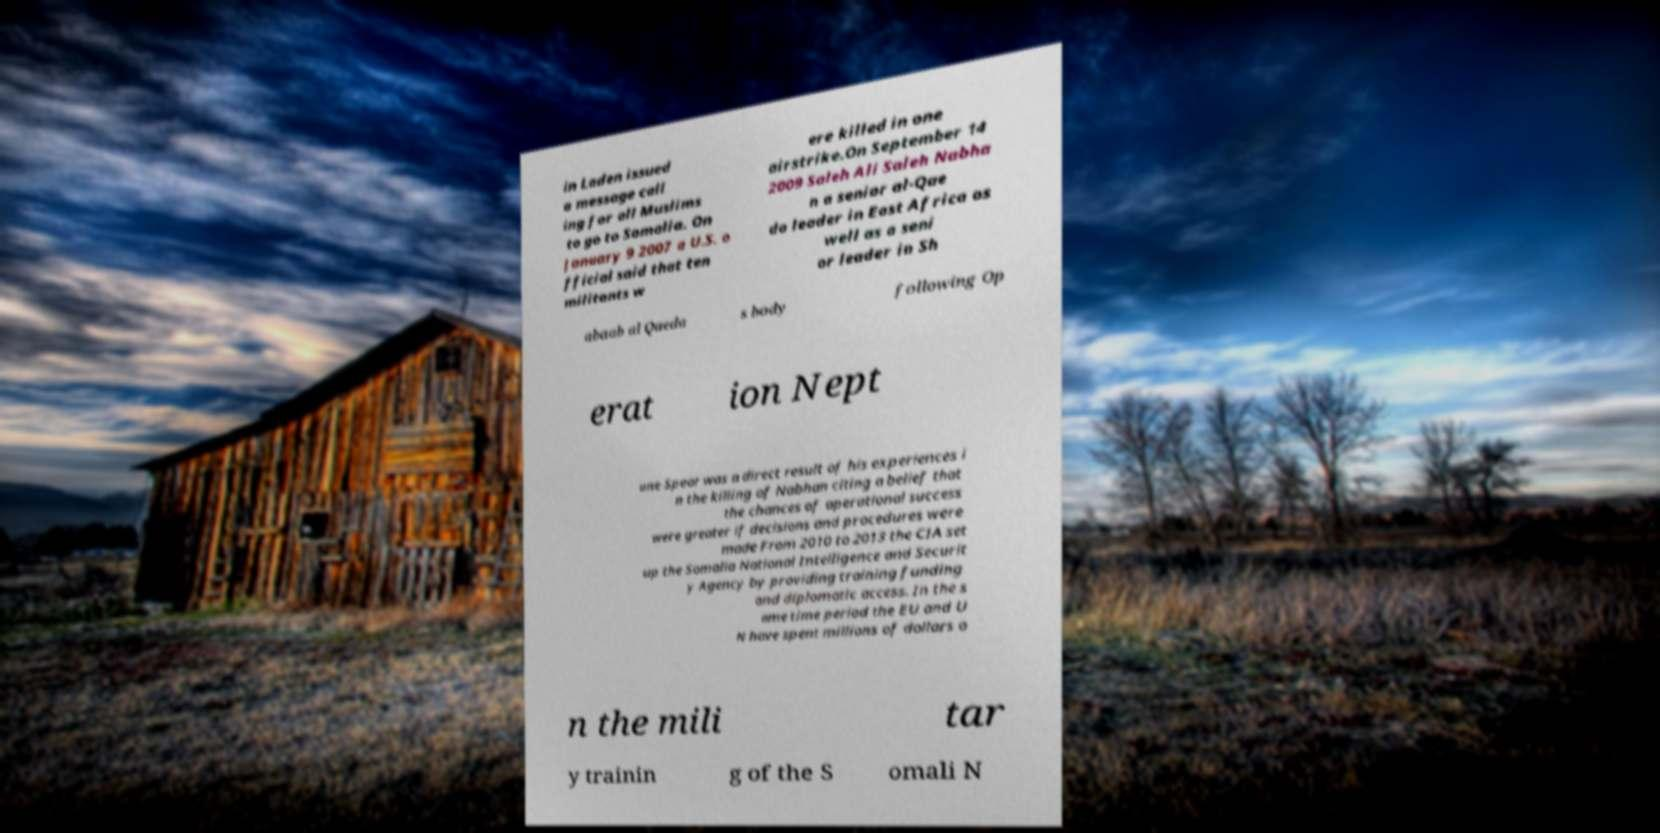Please read and relay the text visible in this image. What does it say? in Laden issued a message call ing for all Muslims to go to Somalia. On January 9 2007 a U.S. o fficial said that ten militants w ere killed in one airstrike.On September 14 2009 Saleh Ali Saleh Nabha n a senior al-Qae da leader in East Africa as well as a seni or leader in Sh abaab al Qaeda s body following Op erat ion Nept une Spear was a direct result of his experiences i n the killing of Nabhan citing a belief that the chances of operational success were greater if decisions and procedures were made From 2010 to 2013 the CIA set up the Somalia National Intelligence and Securit y Agency by providing training funding and diplomatic access. In the s ame time period the EU and U N have spent millions of dollars o n the mili tar y trainin g of the S omali N 